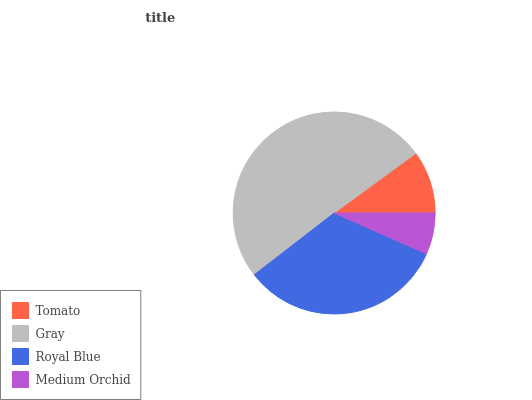Is Medium Orchid the minimum?
Answer yes or no. Yes. Is Gray the maximum?
Answer yes or no. Yes. Is Royal Blue the minimum?
Answer yes or no. No. Is Royal Blue the maximum?
Answer yes or no. No. Is Gray greater than Royal Blue?
Answer yes or no. Yes. Is Royal Blue less than Gray?
Answer yes or no. Yes. Is Royal Blue greater than Gray?
Answer yes or no. No. Is Gray less than Royal Blue?
Answer yes or no. No. Is Royal Blue the high median?
Answer yes or no. Yes. Is Tomato the low median?
Answer yes or no. Yes. Is Gray the high median?
Answer yes or no. No. Is Royal Blue the low median?
Answer yes or no. No. 